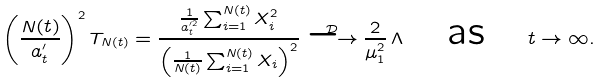Convert formula to latex. <formula><loc_0><loc_0><loc_500><loc_500>\left ( \frac { N ( t ) } { a ^ { \prime } _ { t } } \right ) ^ { 2 } T _ { N ( t ) } = \frac { \frac { 1 } { a ^ { \prime 2 } _ { t } } \sum _ { i = 1 } ^ { N ( t ) } X _ { i } ^ { 2 } } { \left ( \frac { 1 } { N ( t ) } \sum _ { i = 1 } ^ { N ( t ) } X _ { i } \right ) ^ { 2 } } \stackrel { \mathcal { D } } { \longrightarrow } \frac { 2 } { \mu _ { 1 } ^ { 2 } } \, \Lambda \quad \text {as} \quad t \rightarrow \infty .</formula> 